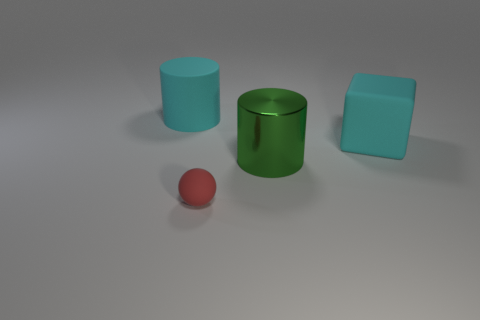What number of large blocks have the same color as the rubber cylinder?
Provide a short and direct response. 1. There is a big cylinder that is on the left side of the sphere; is its color the same as the metal cylinder?
Provide a short and direct response. No. There is a red object; is it the same shape as the big cyan rubber object that is on the left side of the sphere?
Ensure brevity in your answer.  No. What shape is the large object that is the same color as the big matte block?
Provide a short and direct response. Cylinder. There is a red thing that is on the right side of the large object left of the metallic thing; how many metal cylinders are right of it?
Give a very brief answer. 1. There is a cyan matte thing on the left side of the big cyan object that is to the right of the metal cylinder; what size is it?
Your answer should be compact. Large. What size is the red thing that is made of the same material as the big block?
Give a very brief answer. Small. What is the shape of the object that is on the left side of the large block and behind the metal cylinder?
Offer a very short reply. Cylinder. What number of things are either tiny red matte objects or big matte things to the right of the cyan cylinder?
Offer a terse response. 2. Is there another thing that has the same shape as the big metal object?
Offer a terse response. Yes. 